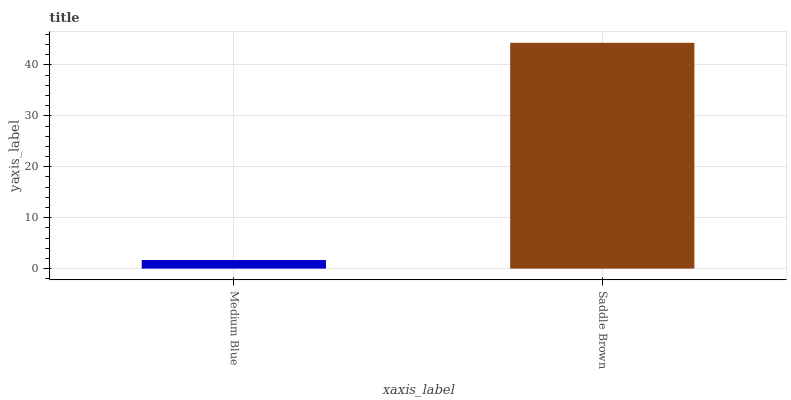Is Medium Blue the minimum?
Answer yes or no. Yes. Is Saddle Brown the maximum?
Answer yes or no. Yes. Is Saddle Brown the minimum?
Answer yes or no. No. Is Saddle Brown greater than Medium Blue?
Answer yes or no. Yes. Is Medium Blue less than Saddle Brown?
Answer yes or no. Yes. Is Medium Blue greater than Saddle Brown?
Answer yes or no. No. Is Saddle Brown less than Medium Blue?
Answer yes or no. No. Is Saddle Brown the high median?
Answer yes or no. Yes. Is Medium Blue the low median?
Answer yes or no. Yes. Is Medium Blue the high median?
Answer yes or no. No. Is Saddle Brown the low median?
Answer yes or no. No. 